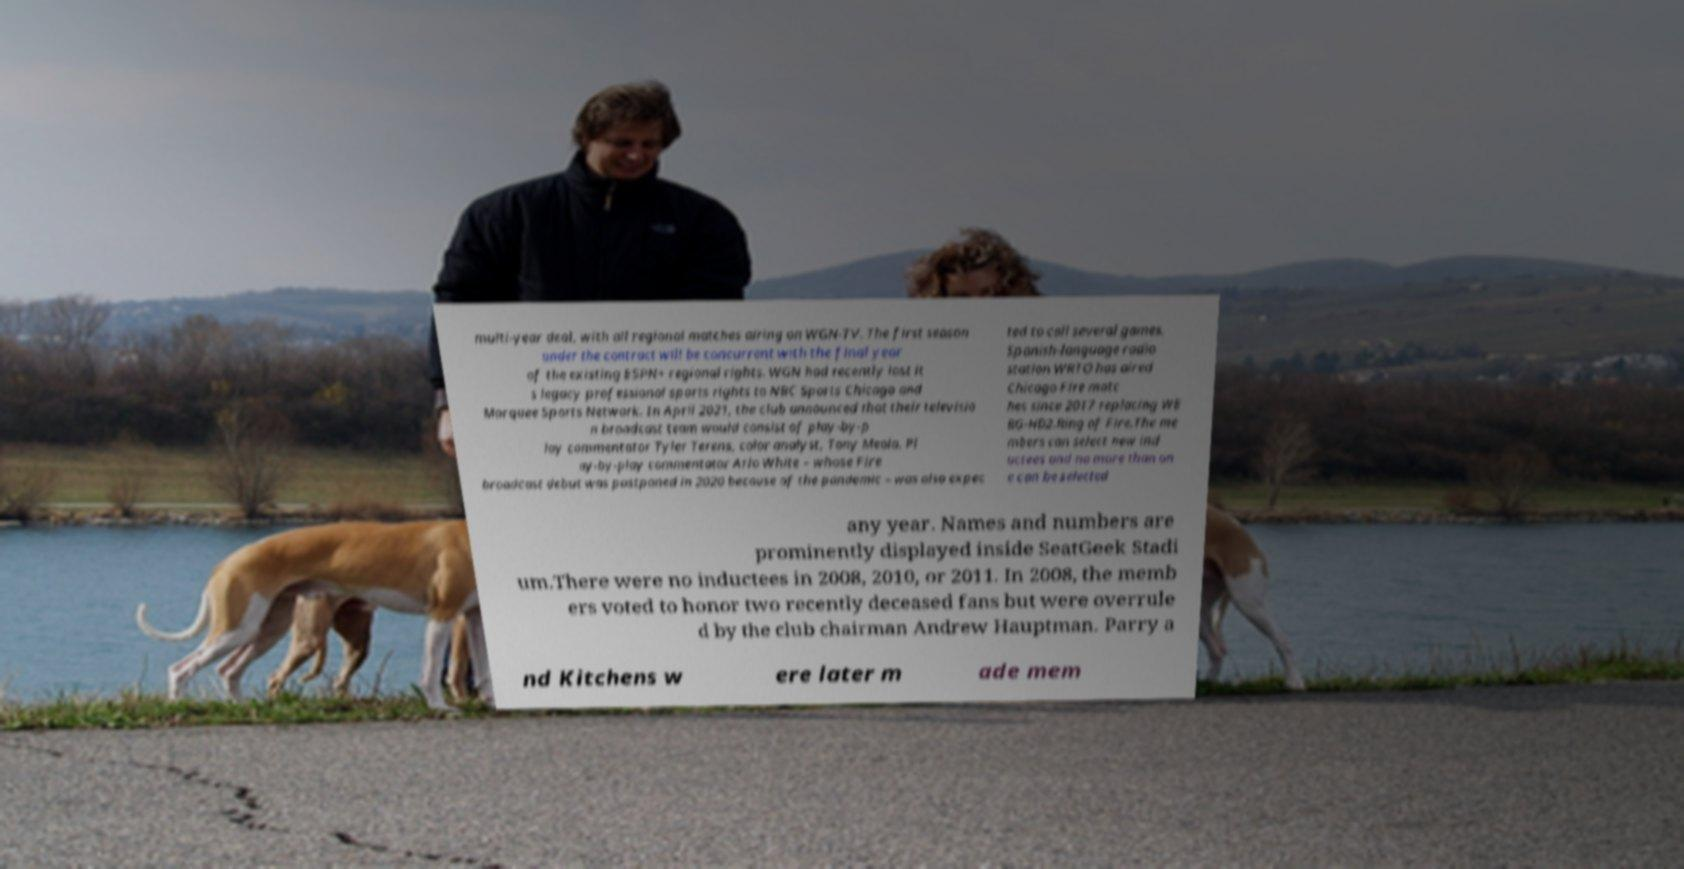Please read and relay the text visible in this image. What does it say? multi-year deal, with all regional matches airing on WGN-TV. The first season under the contract will be concurrent with the final year of the existing ESPN+ regional rights. WGN had recently lost it s legacy professional sports rights to NBC Sports Chicago and Marquee Sports Network. In April 2021, the club announced that their televisio n broadcast team would consist of play-by-p lay commentator Tyler Terens, color analyst, Tony Meola. Pl ay-by-play commentator Arlo White – whose Fire broadcast debut was postponed in 2020 because of the pandemic – was also expec ted to call several games. Spanish-language radio station WRTO has aired Chicago Fire matc hes since 2017 replacing WE BG-HD2.Ring of Fire.The me mbers can select new ind uctees and no more than on e can be selected any year. Names and numbers are prominently displayed inside SeatGeek Stadi um.There were no inductees in 2008, 2010, or 2011. In 2008, the memb ers voted to honor two recently deceased fans but were overrule d by the club chairman Andrew Hauptman. Parry a nd Kitchens w ere later m ade mem 